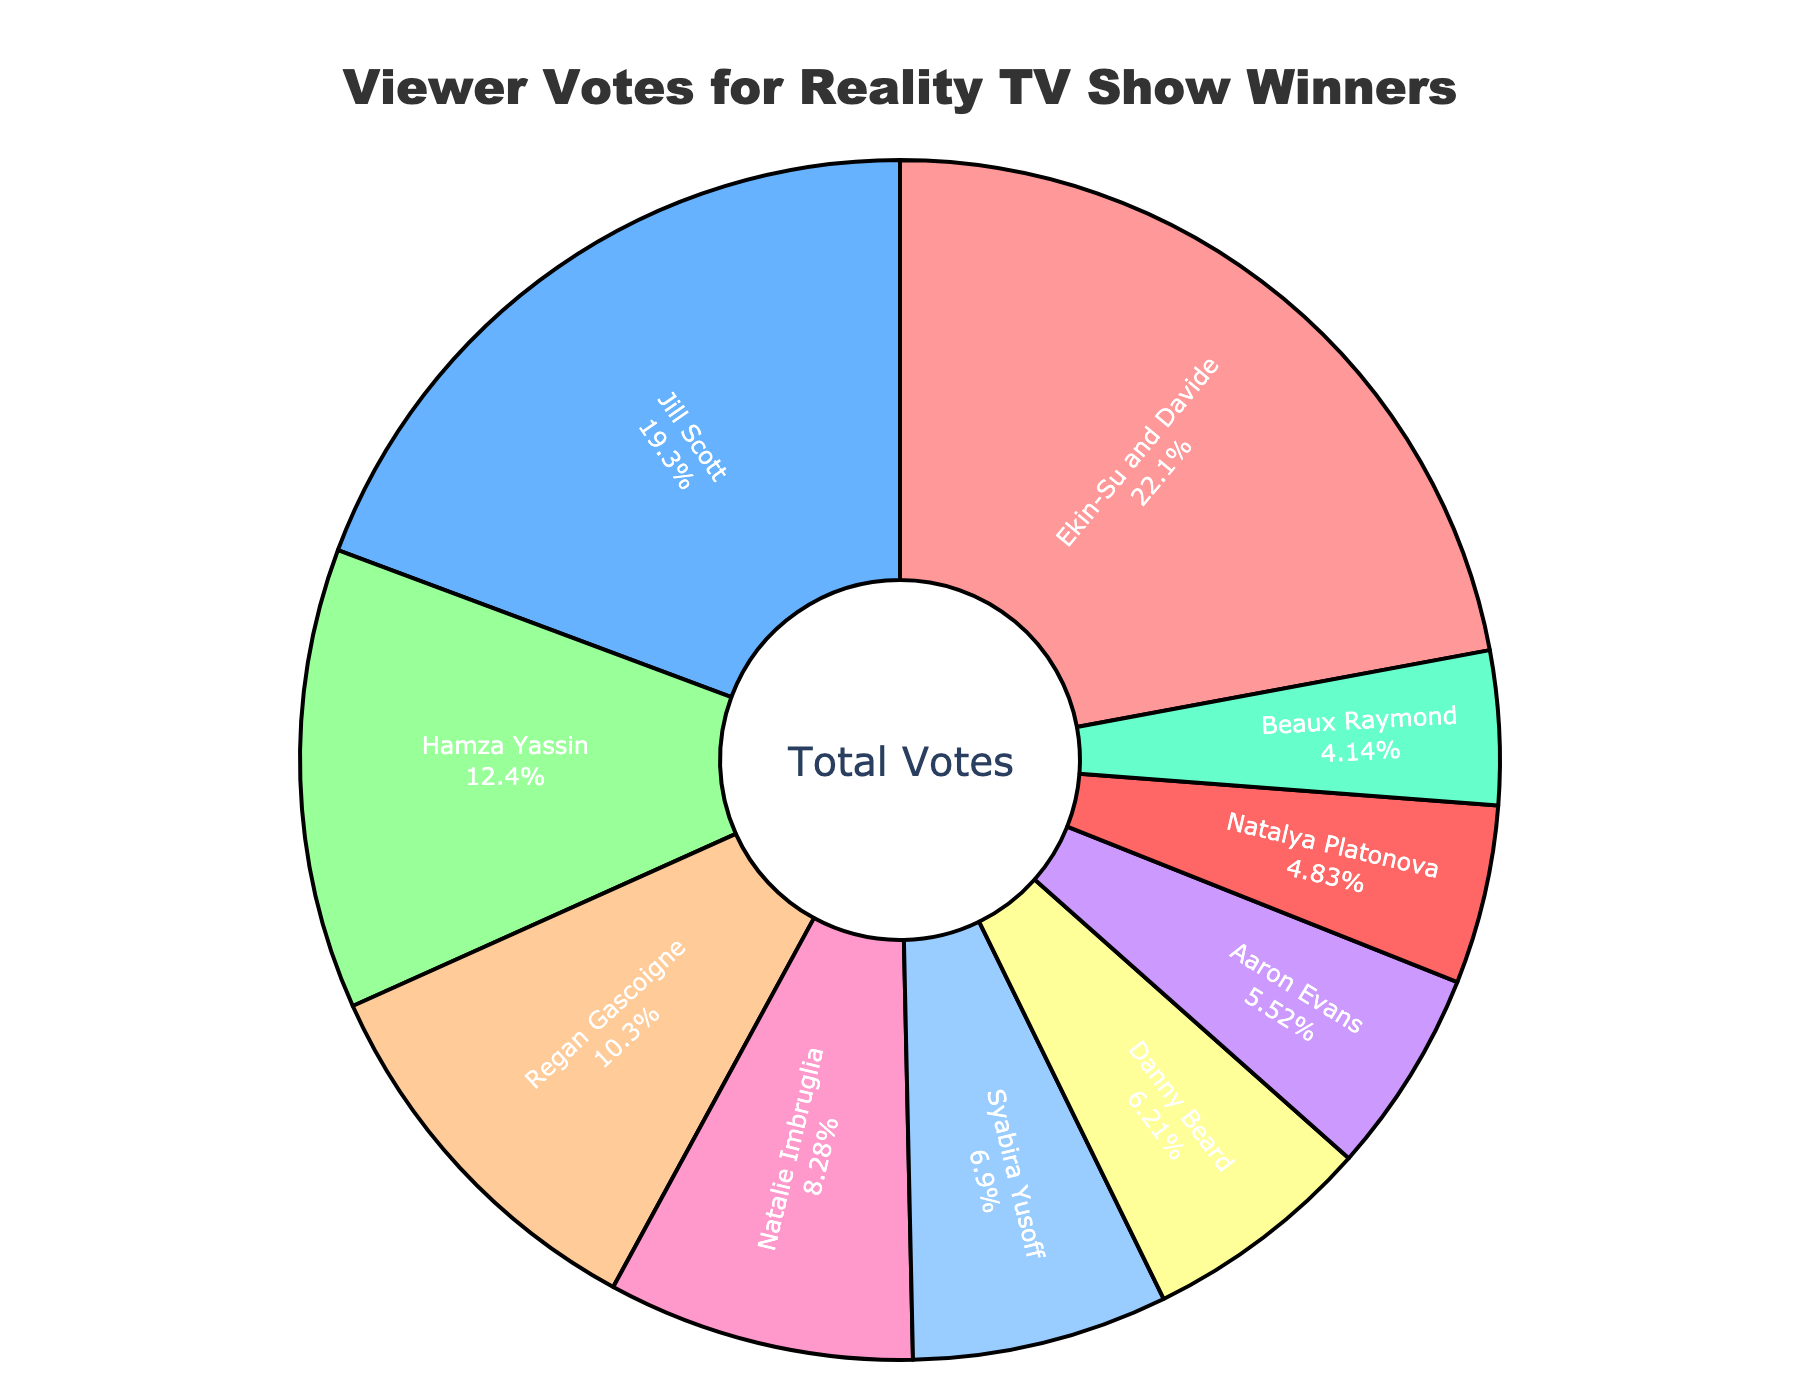Which reality TV show winner received the highest percentage of viewer votes? The slice with the largest size in the pie chart represents the highest percentage of viewer votes, which is labeled as Ekin-Su and Davide from Love Island.
Answer: Ekin-Su and Davide Which two reality TV show winners combined received less than 15% of the viewer votes? By visually identifying smaller slices, Beaux Raymond from Too Hot to Handle (6%) and Natalya Platonova from The Circle (7%) add up to 13%, which is less than 15%.
Answer: Beaux Raymond and Natalya Platonova What is the combined percentage of votes for Regan Gascoigne and Natalie Imbruglia? According to the chart, Regan Gascoigne received 15% and Natalie Imbruglia received 12%. Summing these, 15% + 12% = 27%.
Answer: 27% Who received more viewer votes: Hamza Yassin or Jill Scott? Comparing the sizes of their respective slices, Jill Scott received 28% and Hamza Yassin received 18%. Jill Scott received a higher percentage.
Answer: Jill Scott Which winner received the second-lowest percentage of viewer votes? Identify the two smallest slices. The second-smallest slice is labeled Danny Beard from RuPaul's Drag Race UK with 9%, the smallest slice is for Beaux Raymond.
Answer: Danny Beard Which show winner received slightly more votes than Syabira Yusoff from The Great British Bake Off? Syabira Yusoff received 10%. The next slightly higher percentage is Natalie Imbruglia from The Masked Singer, who received 12%.
Answer: Natalie Imbruglia How much more percentage of votes did Ekin-Su and Davide receive compared to Hamza Yassin? Ekin-Su and Davide received 32%, and Hamza Yassin received 18%. The difference is 32% - 18% = 14%.
Answer: 14% Who are the winners with votes adding up to exactly 50% of viewer votes? Find a combination of winners where the sum equals 50%. Jill Scott (28%) and Regan Gascoigne (15%) add up to 43%, adding Natatya Platonova (7%) equals 50%.
Answer: Jill Scott, Regan Gascoigne, and Natalya Platonova Which color slice represents the show winner Syabira Yusoff? Visually identifying the pie chart's colors, Syabira Yusoff's slice, labeled, is colored at a specific position. Verify it's the third slice from the top. Without precise colors, visual verification points out her specific section.
Answer: Verify based on position in chart What is the difference in viewer votes between the winner with the highest percentage and the winner with the lowest percentage? The highest percentage is 32% for Ekin-Su and Davide, and the lowest is 6% for Beaux Raymond. The difference is 32% - 6% = 26%.
Answer: 26% 